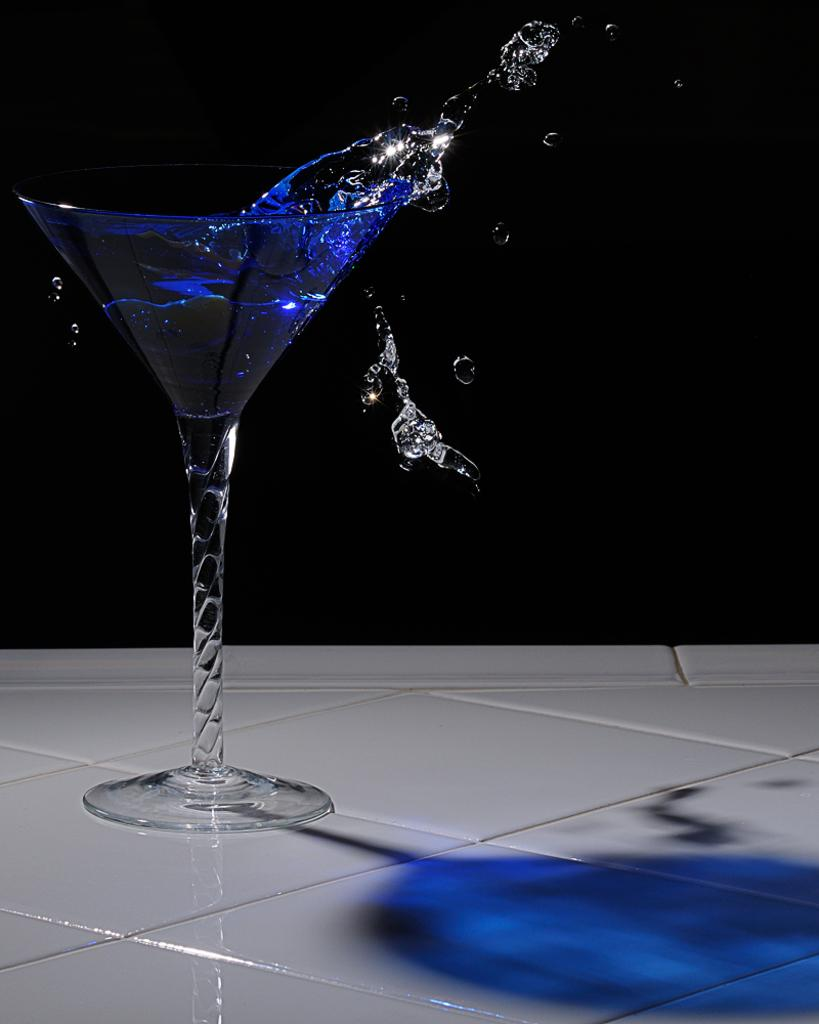What type of table is in the image? There is a white table in the image. What is on the table? There is a wine glass on the table. What is inside the wine glass? The wine glass contains a blue liquid. Is the blue liquid staying inside the wine glass? No, the blue liquid is flowing out of the wine glass. What type of property does the governor own in the image? There is no mention of a governor or any property in the image. 